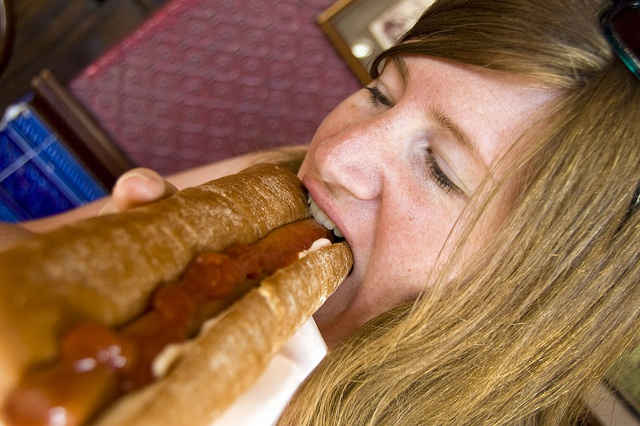Describe the objects in this image and their specific colors. I can see people in gray and tan tones and hot dog in gray, brown, maroon, and tan tones in this image. 